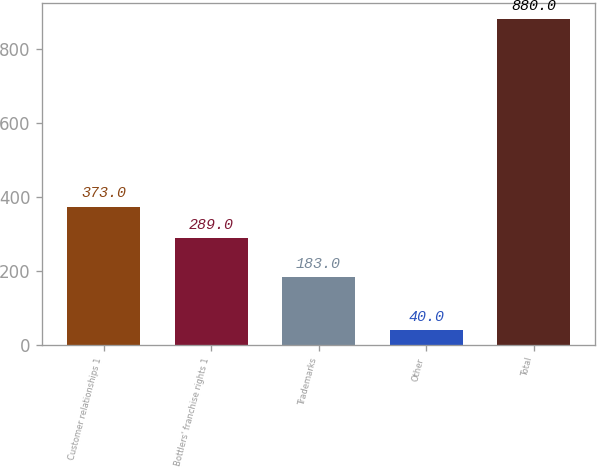Convert chart. <chart><loc_0><loc_0><loc_500><loc_500><bar_chart><fcel>Customer relationships 1<fcel>Bottlers' franchise rights 1<fcel>Trademarks<fcel>Other<fcel>Total<nl><fcel>373<fcel>289<fcel>183<fcel>40<fcel>880<nl></chart> 